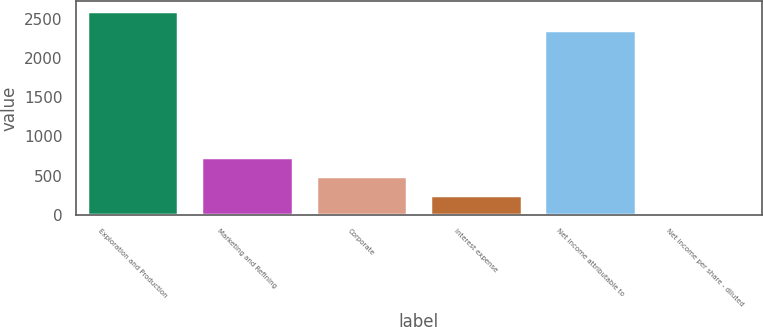Convert chart. <chart><loc_0><loc_0><loc_500><loc_500><bar_chart><fcel>Exploration and Production<fcel>Marketing and Refining<fcel>Corporate<fcel>Interest expense<fcel>Net income attributable to<fcel>Net income per share - diluted<nl><fcel>2601.58<fcel>731.98<fcel>490.4<fcel>248.82<fcel>2360<fcel>7.24<nl></chart> 